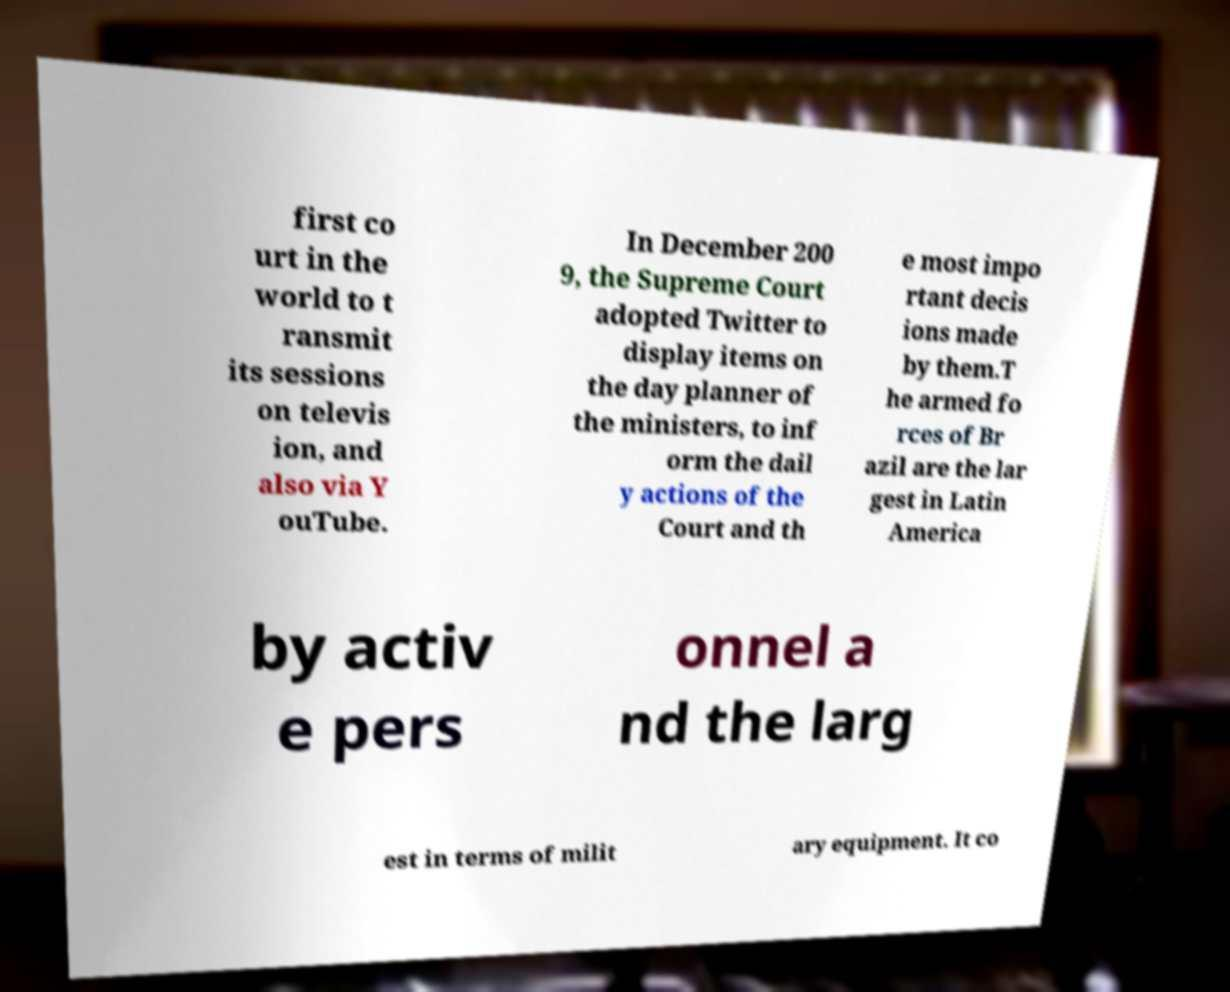Please read and relay the text visible in this image. What does it say? first co urt in the world to t ransmit its sessions on televis ion, and also via Y ouTube. In December 200 9, the Supreme Court adopted Twitter to display items on the day planner of the ministers, to inf orm the dail y actions of the Court and th e most impo rtant decis ions made by them.T he armed fo rces of Br azil are the lar gest in Latin America by activ e pers onnel a nd the larg est in terms of milit ary equipment. It co 